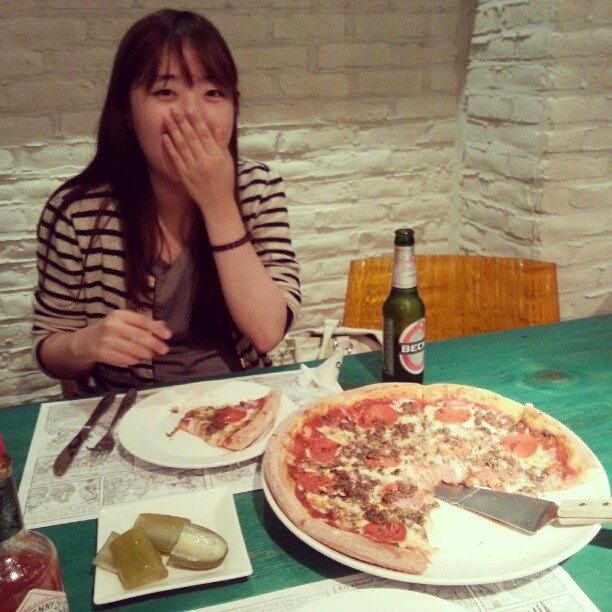Describe the objects in this image and their specific colors. I can see dining table in gray, beige, darkgray, and tan tones, people in gray, black, brown, and maroon tones, pizza in gray, tan, and brown tones, chair in gray, brown, teal, and tan tones, and bottle in gray, black, darkgreen, and tan tones in this image. 